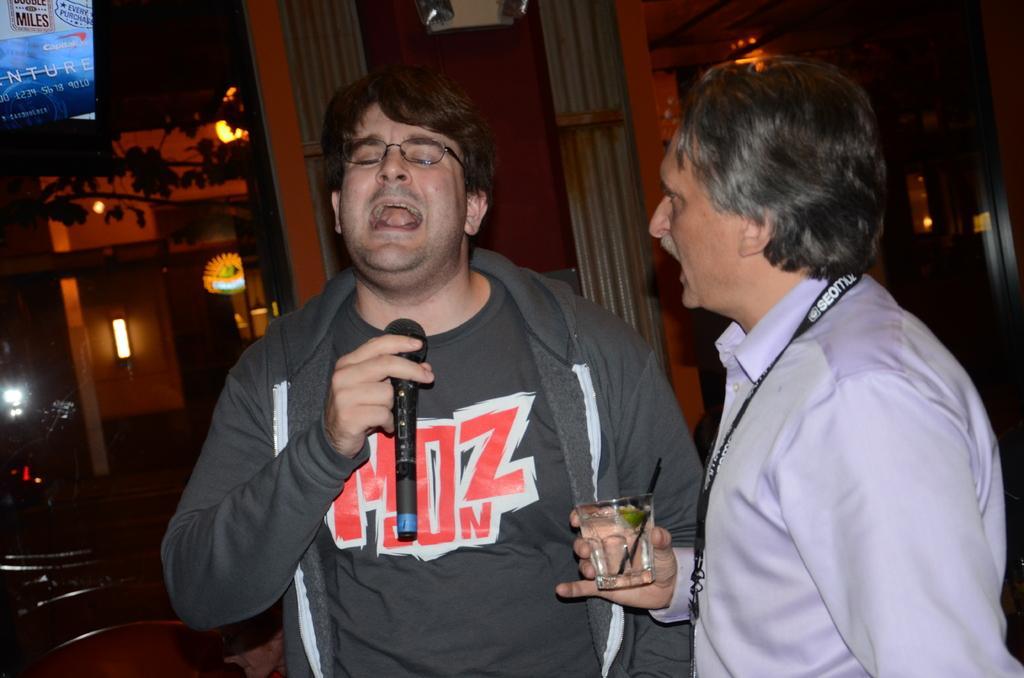Please provide a concise description of this image. Here I can see two men. The man who is on the right side is holding a glass in the hand and looking at the another man who is holding a mike in the hand and singing. On the left side there are few wooden objects. In the background there is a building and few lights in the dark. In the top left-hand corner few leaves are visible and there is a screen on which I can see some text. 